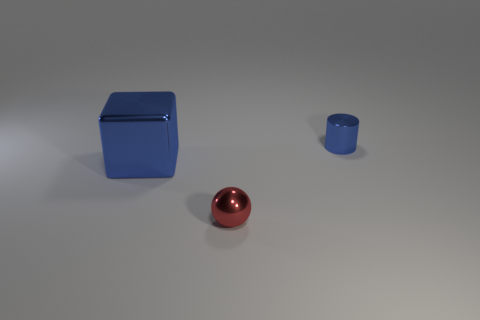Add 1 small red things. How many objects exist? 4 Subtract all blocks. How many objects are left? 2 Add 1 small blue things. How many small blue things are left? 2 Add 1 purple rubber cylinders. How many purple rubber cylinders exist? 1 Subtract 0 cyan cubes. How many objects are left? 3 Subtract all big metallic objects. Subtract all tiny blue metal cylinders. How many objects are left? 1 